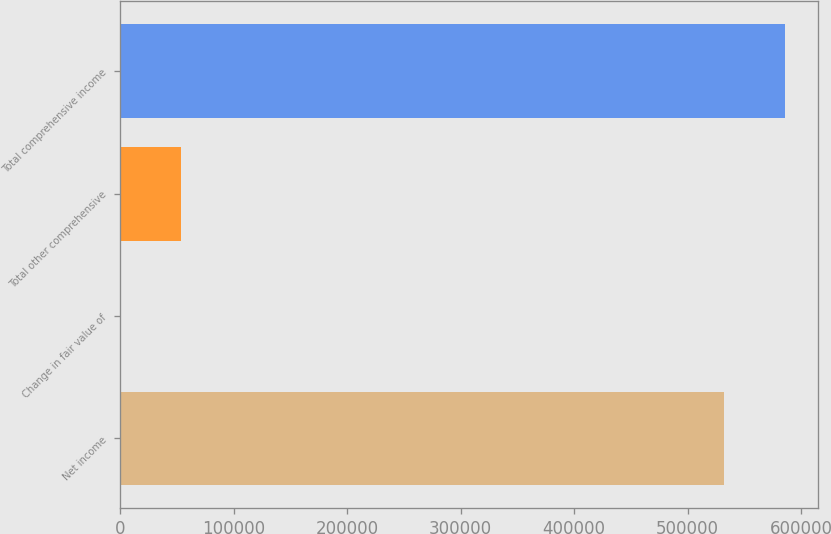<chart> <loc_0><loc_0><loc_500><loc_500><bar_chart><fcel>Net income<fcel>Change in fair value of<fcel>Total other comprehensive<fcel>Total comprehensive income<nl><fcel>532357<fcel>456<fcel>53691.7<fcel>585593<nl></chart> 